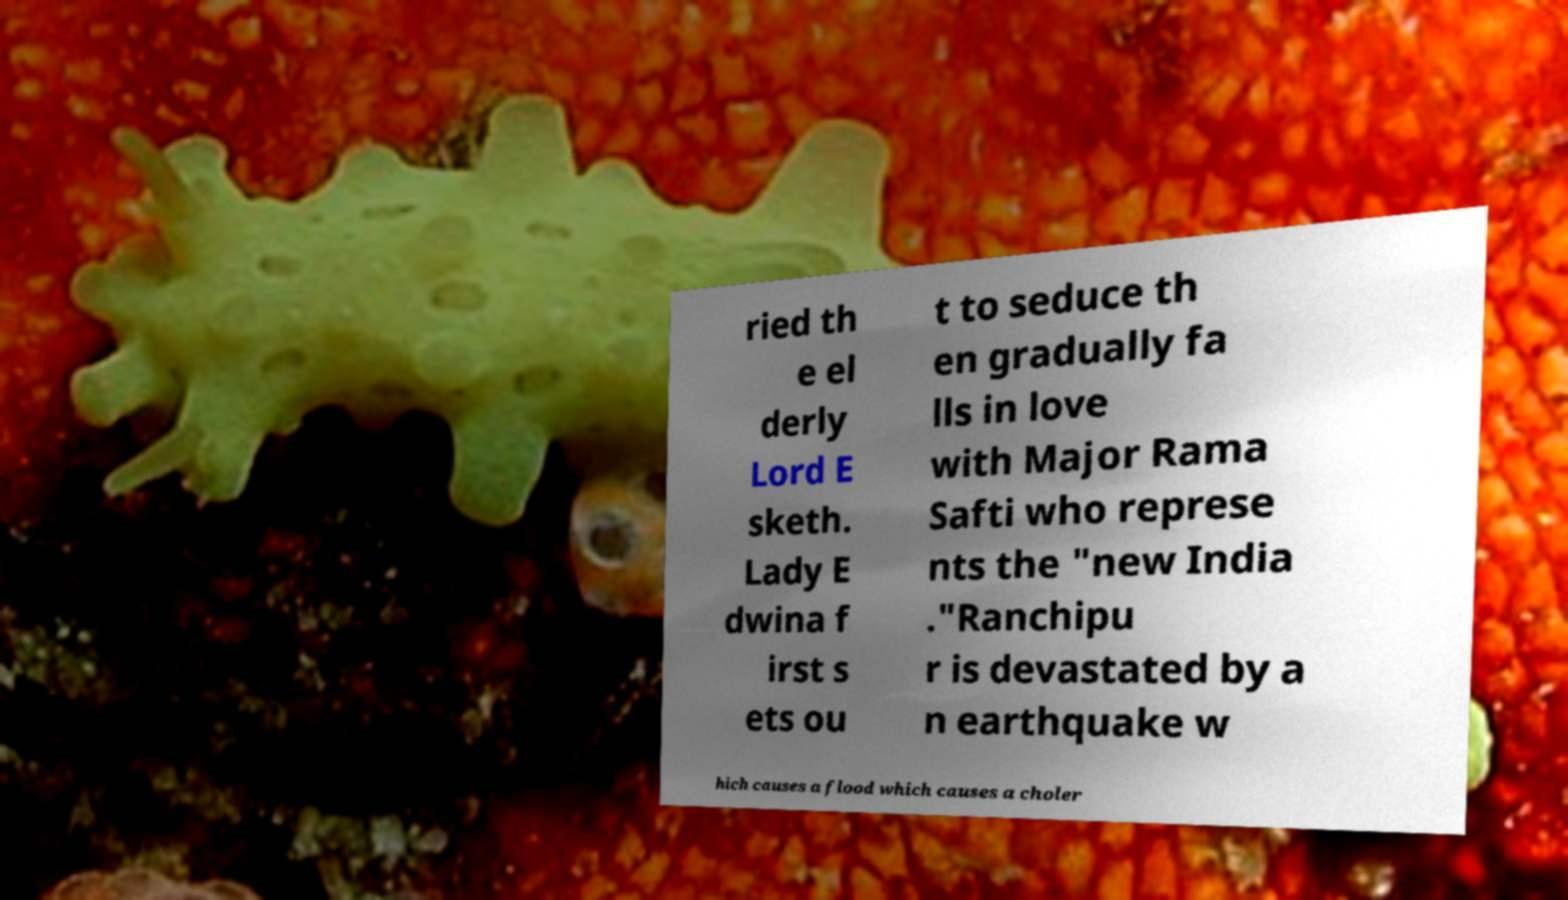Could you extract and type out the text from this image? ried th e el derly Lord E sketh. Lady E dwina f irst s ets ou t to seduce th en gradually fa lls in love with Major Rama Safti who represe nts the "new India ."Ranchipu r is devastated by a n earthquake w hich causes a flood which causes a choler 